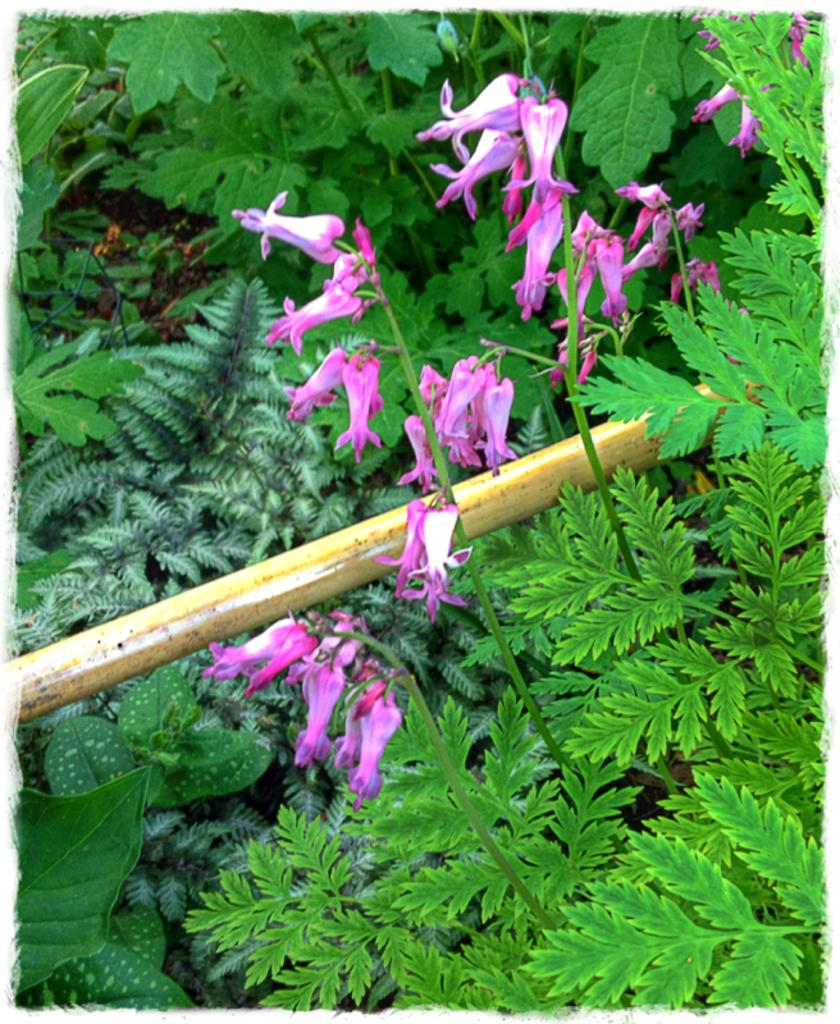What color are the flowers on the plant in the image? The flowers on the plant are pink. What color are the leaves at the bottom of the plant? The leaves at the bottom of the plant are green. What can be seen on the left side of the image? There is a steel pipe on the left side of the image. How many trees can be seen in the image? There are no trees present in the image; it features a plant with pink flowers and green leaves, along with a steel pipe on the left side. 